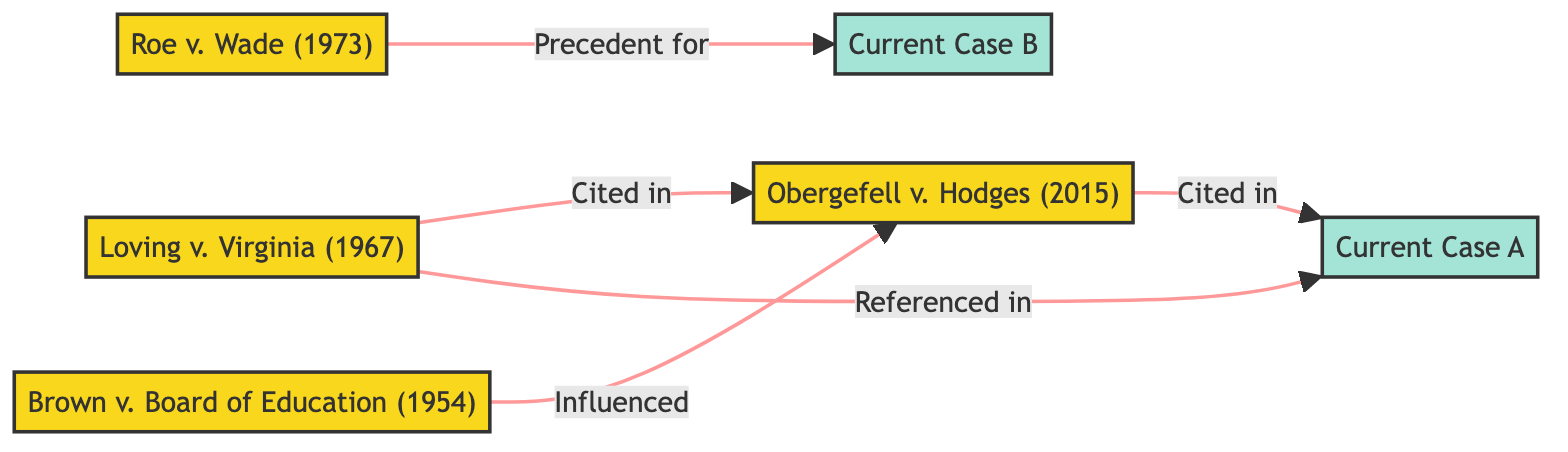What is the total number of landmark cases displayed in the diagram? To find the total number of landmark cases, I count the nodes labeled as landmark: Brown v. Board of Education, Loving v. Virginia, Roe v. Wade, and Obergefell v. Hodges. This gives us a total of four landmark cases.
Answer: 4 Which case influenced Obergefell v. Hodges? I look for the edge leading into Obergefell v. Hodges. The edge labeled "Influenced" from Brown v. Board of Education indicates that it influenced Obergefell v. Hodges.
Answer: Brown v. Board of Education How many current cases are represented in the diagram? I count the nodes labeled as current cases: Current Case A and Current Case B. This totals two current cases represented in the diagram.
Answer: 2 Which case is referenced in Current Case A? I examine the edges leading to Current Case A. The edge labeled "Referenced in" from Loving v. Virginia shows it is referenced in Current Case A.
Answer: Loving v. Virginia What relationship does Roe v. Wade have with Current Case B? I look for the edge connecting Roe v. Wade to Current Case B. The edge labeled "Precedent for" indicates that Roe v. Wade serves as a precedent for Current Case B.
Answer: Precedent for Who cited Obergefell v. Hodges in Current Case A? I check the edges leading to Current Case A. The edge labeled "Cited in" shows that Obergefell v. Hodges is cited in Current Case A, which doesn't involve other cases as it only states it is cited. I also note the connection comes from two cases: Loving v. Virginia and Obergefell v. Hodges itself.
Answer: Obergefell v. Hodges What is the primary theme connecting Brown v. Board of Education and Obergefell v. Hodges? I analyze the directed relationship, where Brown v. Board of Education is directed toward Obergefell v. Hodges with the label "Influenced." The primary theme would be civil rights and equality laws evolving from the decisions established in the earlier case.
Answer: Civil rights and equality How many edges are present among the landmark cases? I count the edges connecting the landmark cases visible in the diagram. I see connections from Brown v. Board of Education to Obergefell v. Hodges, Loving v. Virginia to Obergefell v. Hodges, and Loving v. Virginia and Roe v. Wade directing toward current cases. There are three unique connections or edges among the landmark cases.
Answer: 3 Which two historical landmark cases are directly connected to Current Case A? I examine the diagram for edges leading to Current Case A. I find two edges: one from Loving v. Virginia labeled "Referenced in" and one from Obergefell v. Hodges labeled "Cited in." Thus, both cases connect to Current Case A.
Answer: Loving v. Virginia, Obergefell v. Hodges 